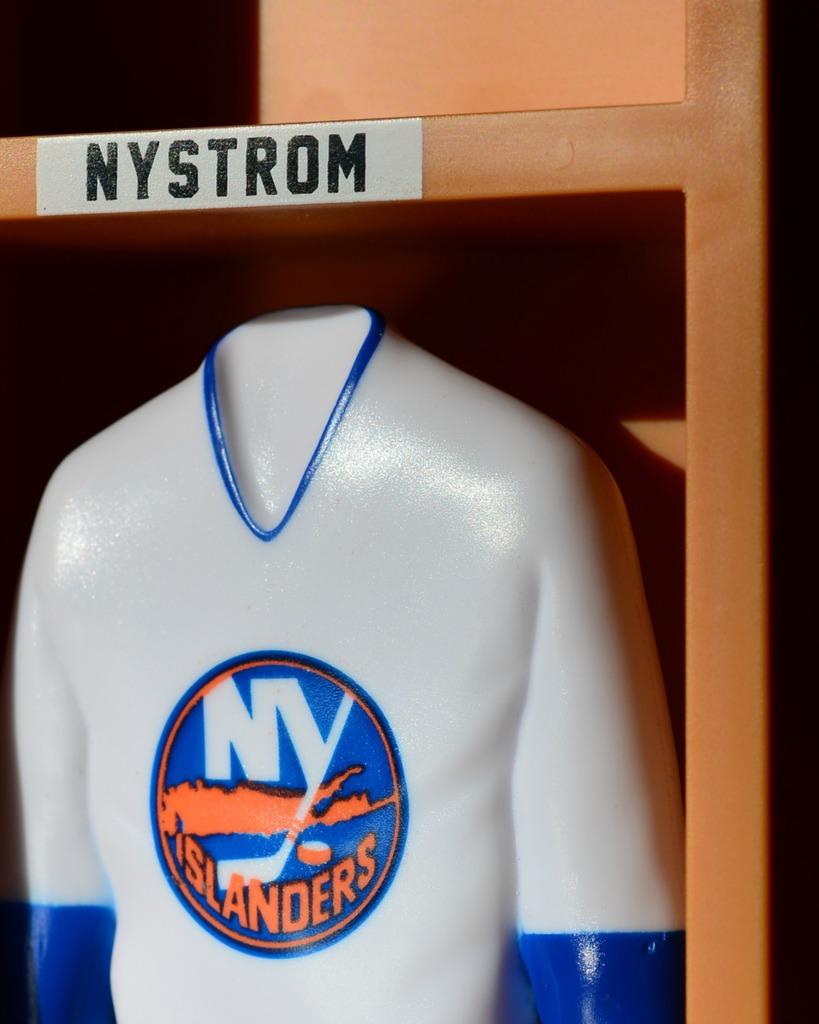What team is this jersey?
Give a very brief answer. Ny islanders. 